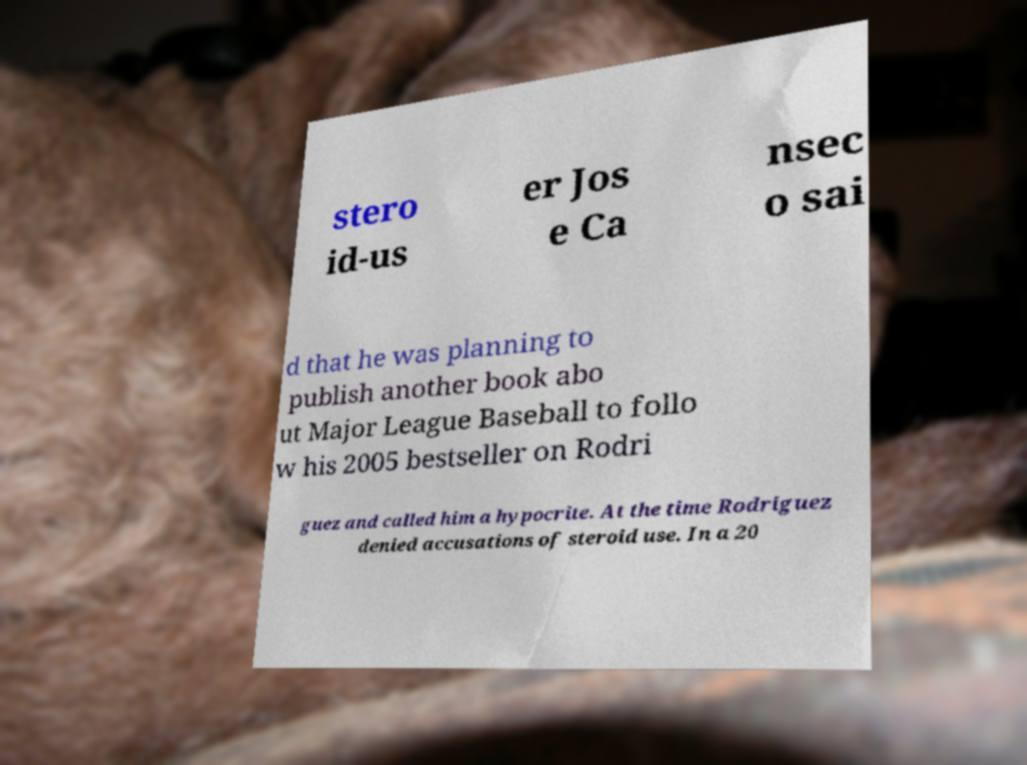Please identify and transcribe the text found in this image. stero id-us er Jos e Ca nsec o sai d that he was planning to publish another book abo ut Major League Baseball to follo w his 2005 bestseller on Rodri guez and called him a hypocrite. At the time Rodriguez denied accusations of steroid use. In a 20 